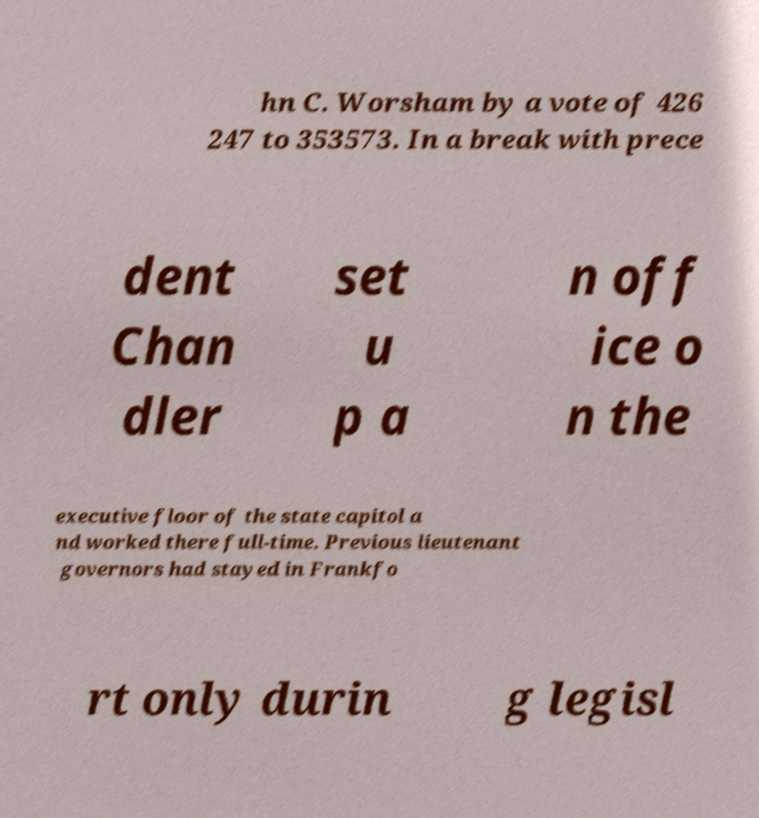Could you extract and type out the text from this image? hn C. Worsham by a vote of 426 247 to 353573. In a break with prece dent Chan dler set u p a n off ice o n the executive floor of the state capitol a nd worked there full-time. Previous lieutenant governors had stayed in Frankfo rt only durin g legisl 